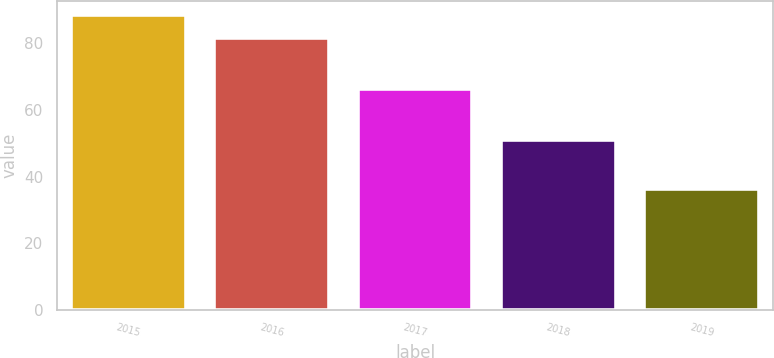<chart> <loc_0><loc_0><loc_500><loc_500><bar_chart><fcel>2015<fcel>2016<fcel>2017<fcel>2018<fcel>2019<nl><fcel>88.5<fcel>81.6<fcel>66.2<fcel>50.9<fcel>36.3<nl></chart> 